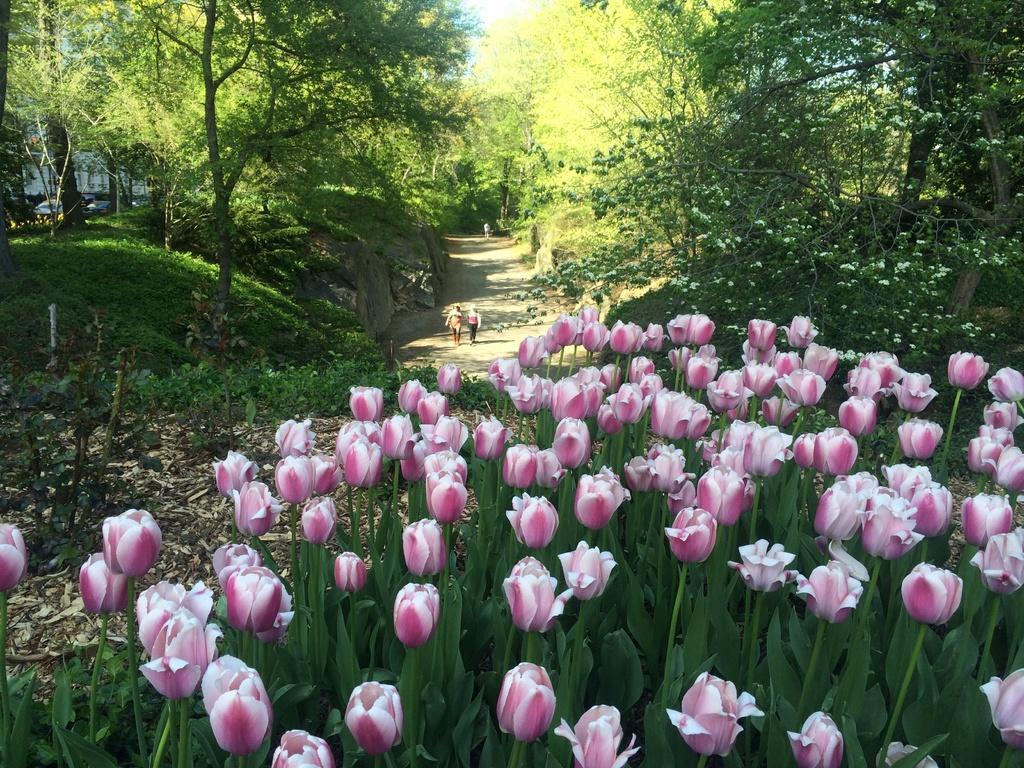How would you summarize this image in a sentence or two? In this image, we can see some flowers, there are some plants and trees, there is a way and we can see two people walking. 